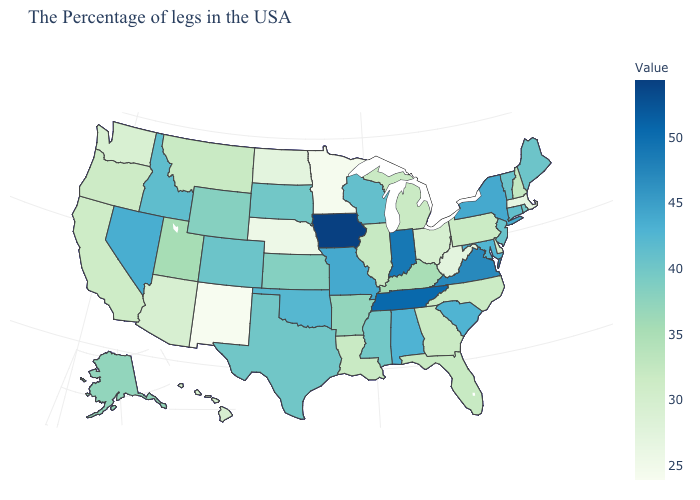Which states have the lowest value in the USA?
Be succinct. New Mexico. Does the map have missing data?
Give a very brief answer. No. Which states have the lowest value in the USA?
Quick response, please. New Mexico. Which states hav the highest value in the MidWest?
Write a very short answer. Iowa. Which states have the lowest value in the West?
Concise answer only. New Mexico. Among the states that border Kentucky , which have the lowest value?
Concise answer only. West Virginia. Among the states that border Connecticut , does Massachusetts have the lowest value?
Answer briefly. Yes. 